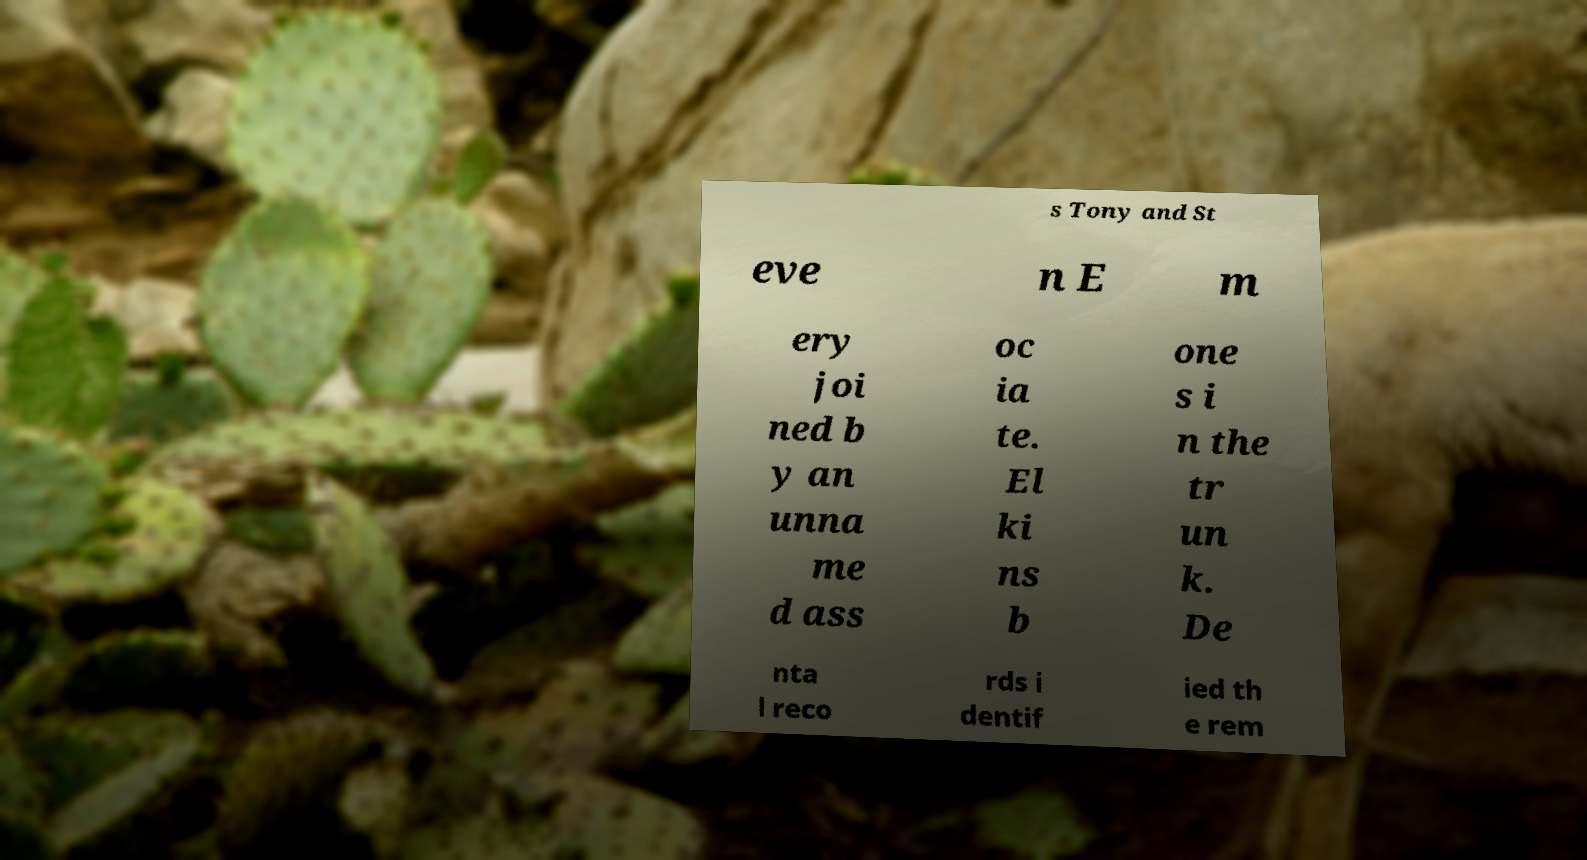There's text embedded in this image that I need extracted. Can you transcribe it verbatim? s Tony and St eve n E m ery joi ned b y an unna me d ass oc ia te. El ki ns b one s i n the tr un k. De nta l reco rds i dentif ied th e rem 